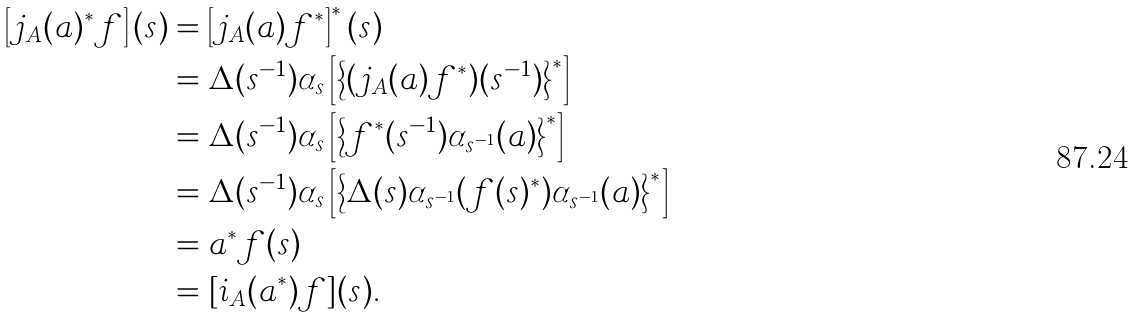Convert formula to latex. <formula><loc_0><loc_0><loc_500><loc_500>\left [ j _ { A } ( a ) ^ { * } f \right ] ( s ) & = \left [ j _ { A } ( a ) f ^ { * } \right ] ^ { * } ( s ) \\ & = \Delta ( s ^ { - 1 } ) \alpha _ { s } \left [ \left \{ ( j _ { A } ( a ) f ^ { * } ) ( s ^ { - 1 } ) \right \} ^ { * } \right ] \\ & = \Delta ( s ^ { - 1 } ) \alpha _ { s } \left [ \left \{ f ^ { * } ( s ^ { - 1 } ) \alpha _ { s ^ { - 1 } } ( a ) \right \} ^ { * } \right ] \\ & = \Delta ( s ^ { - 1 } ) \alpha _ { s } \left [ \left \{ \Delta ( s ) \alpha _ { s ^ { - 1 } } ( f ( s ) ^ { * } ) \alpha _ { s ^ { - 1 } } ( a ) \right \} ^ { * } \right ] \\ & = a ^ { * } f ( s ) \\ & = [ i _ { A } ( a ^ { * } ) f ] ( s ) .</formula> 